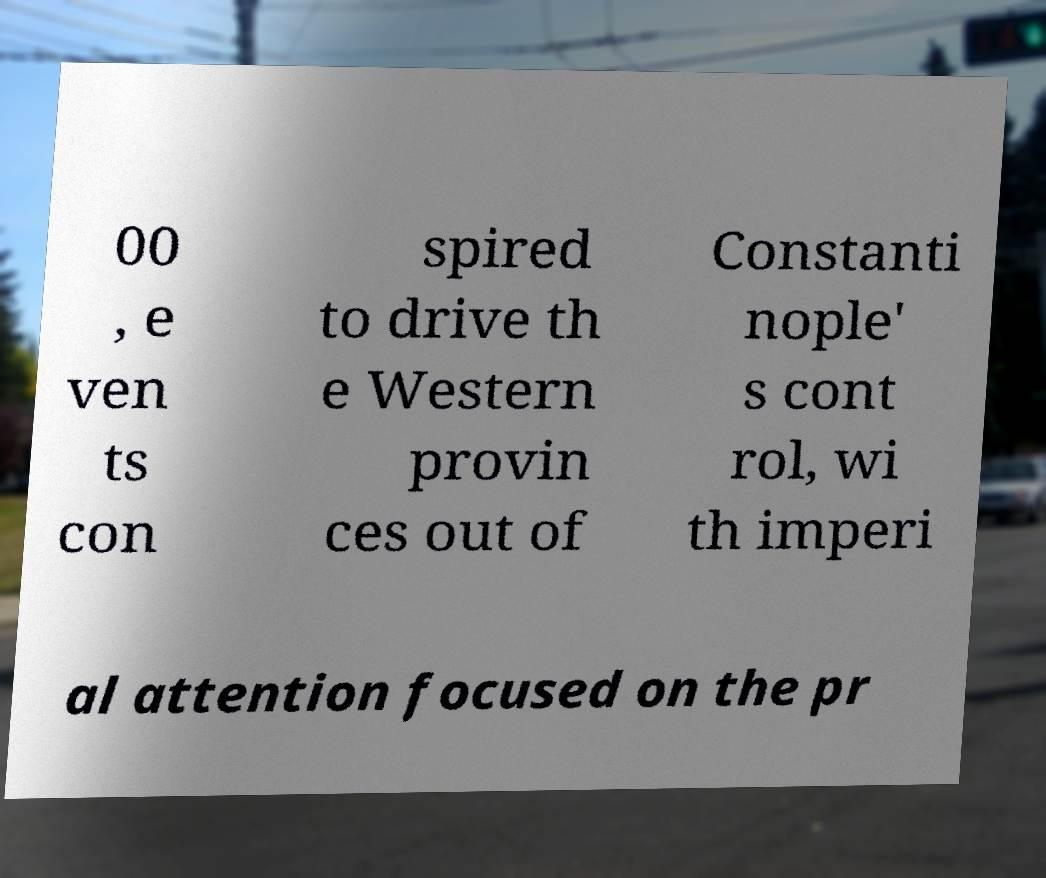Please identify and transcribe the text found in this image. 00 , e ven ts con spired to drive th e Western provin ces out of Constanti nople' s cont rol, wi th imperi al attention focused on the pr 